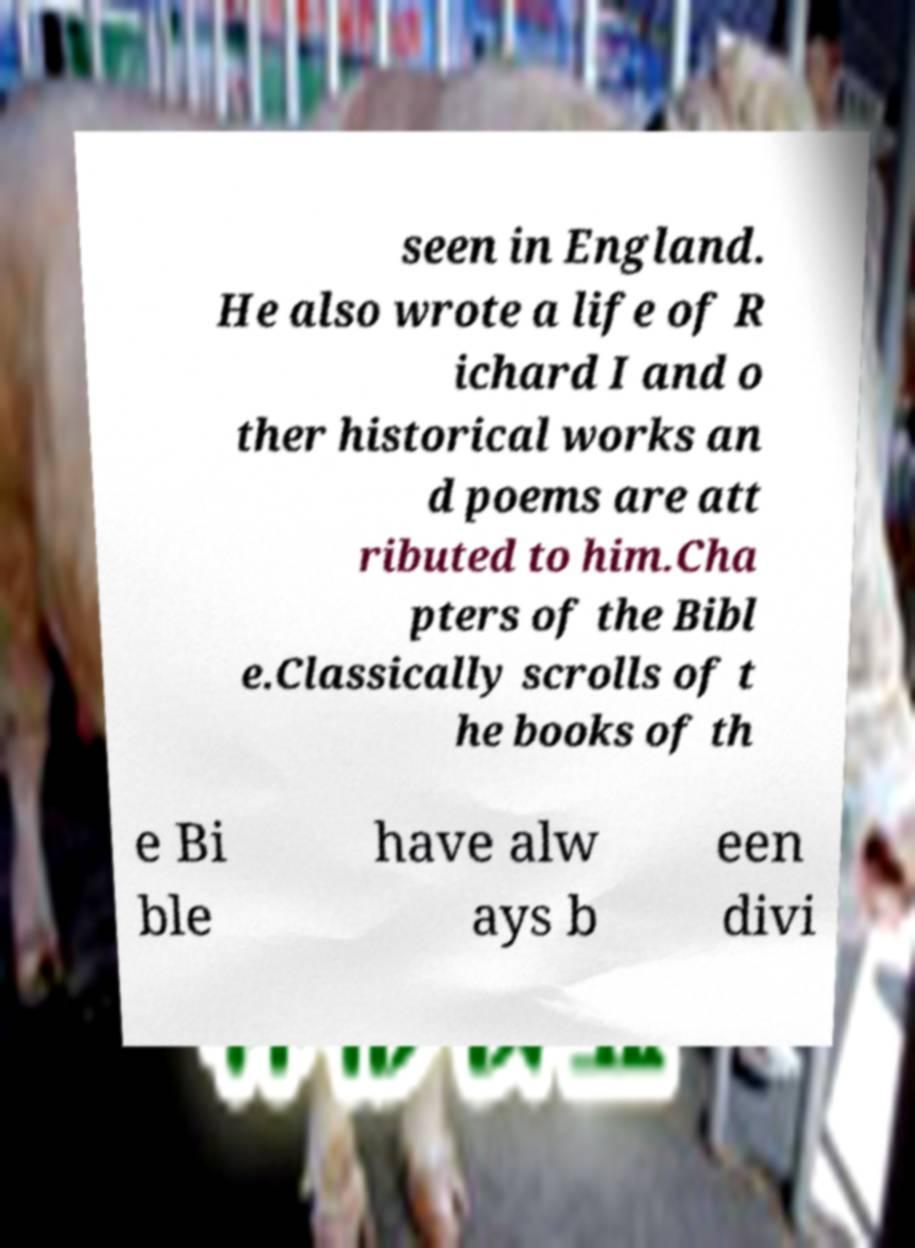Please identify and transcribe the text found in this image. seen in England. He also wrote a life of R ichard I and o ther historical works an d poems are att ributed to him.Cha pters of the Bibl e.Classically scrolls of t he books of th e Bi ble have alw ays b een divi 